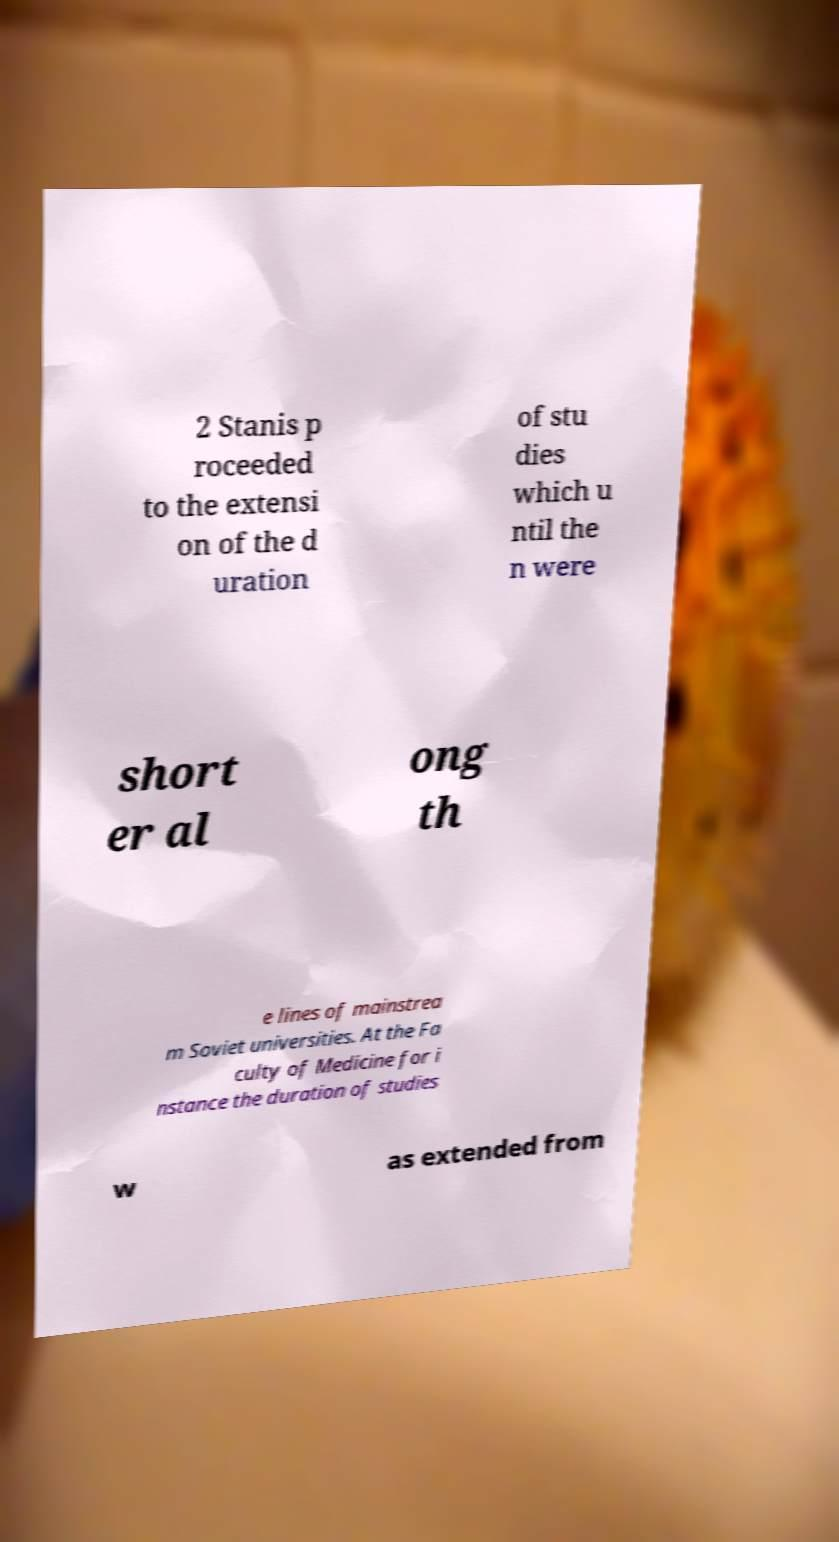What messages or text are displayed in this image? I need them in a readable, typed format. 2 Stanis p roceeded to the extensi on of the d uration of stu dies which u ntil the n were short er al ong th e lines of mainstrea m Soviet universities. At the Fa culty of Medicine for i nstance the duration of studies w as extended from 